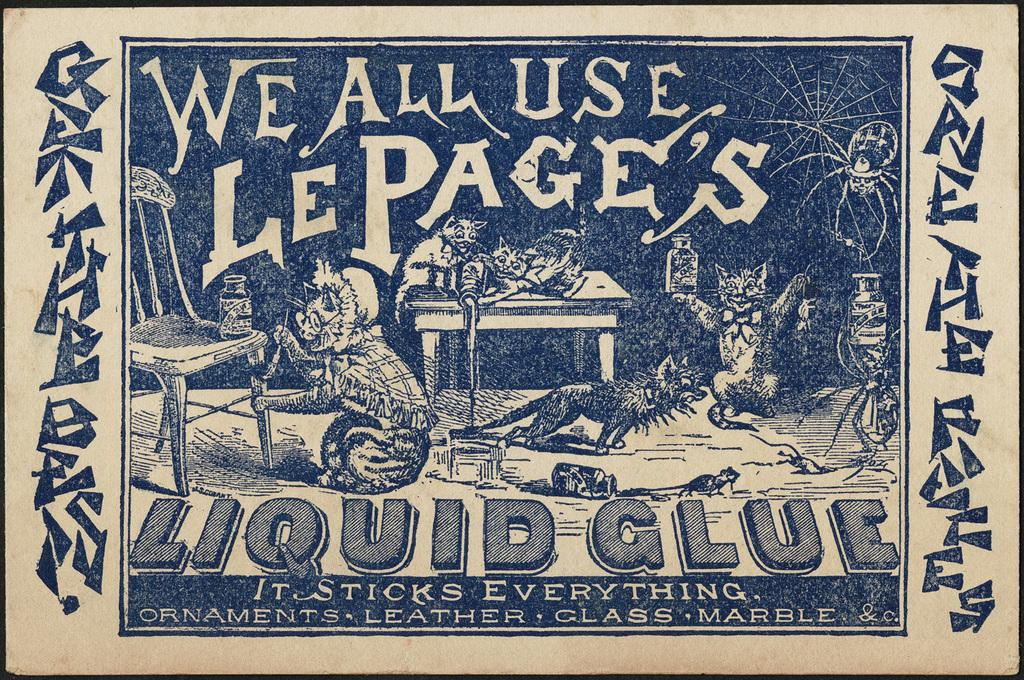What is in the foreground of the poster in the image? The poster has text in the foreground. What type of animals are depicted on the poster? There are images of cats on the poster. What other objects can be seen on the poster besides the animals? There is an image of a chair, a bottle, and a rat on the poster. Are there any insects depicted on the poster? Yes, there is an image of a spider on the poster. What other objects might be present on the poster? There are other objects depicted on the poster, but their specific details are not mentioned in the provided facts. What type of butter is being used to create fear in the image? There is no butter present in the image, nor is there any indication of fear being depicted. 